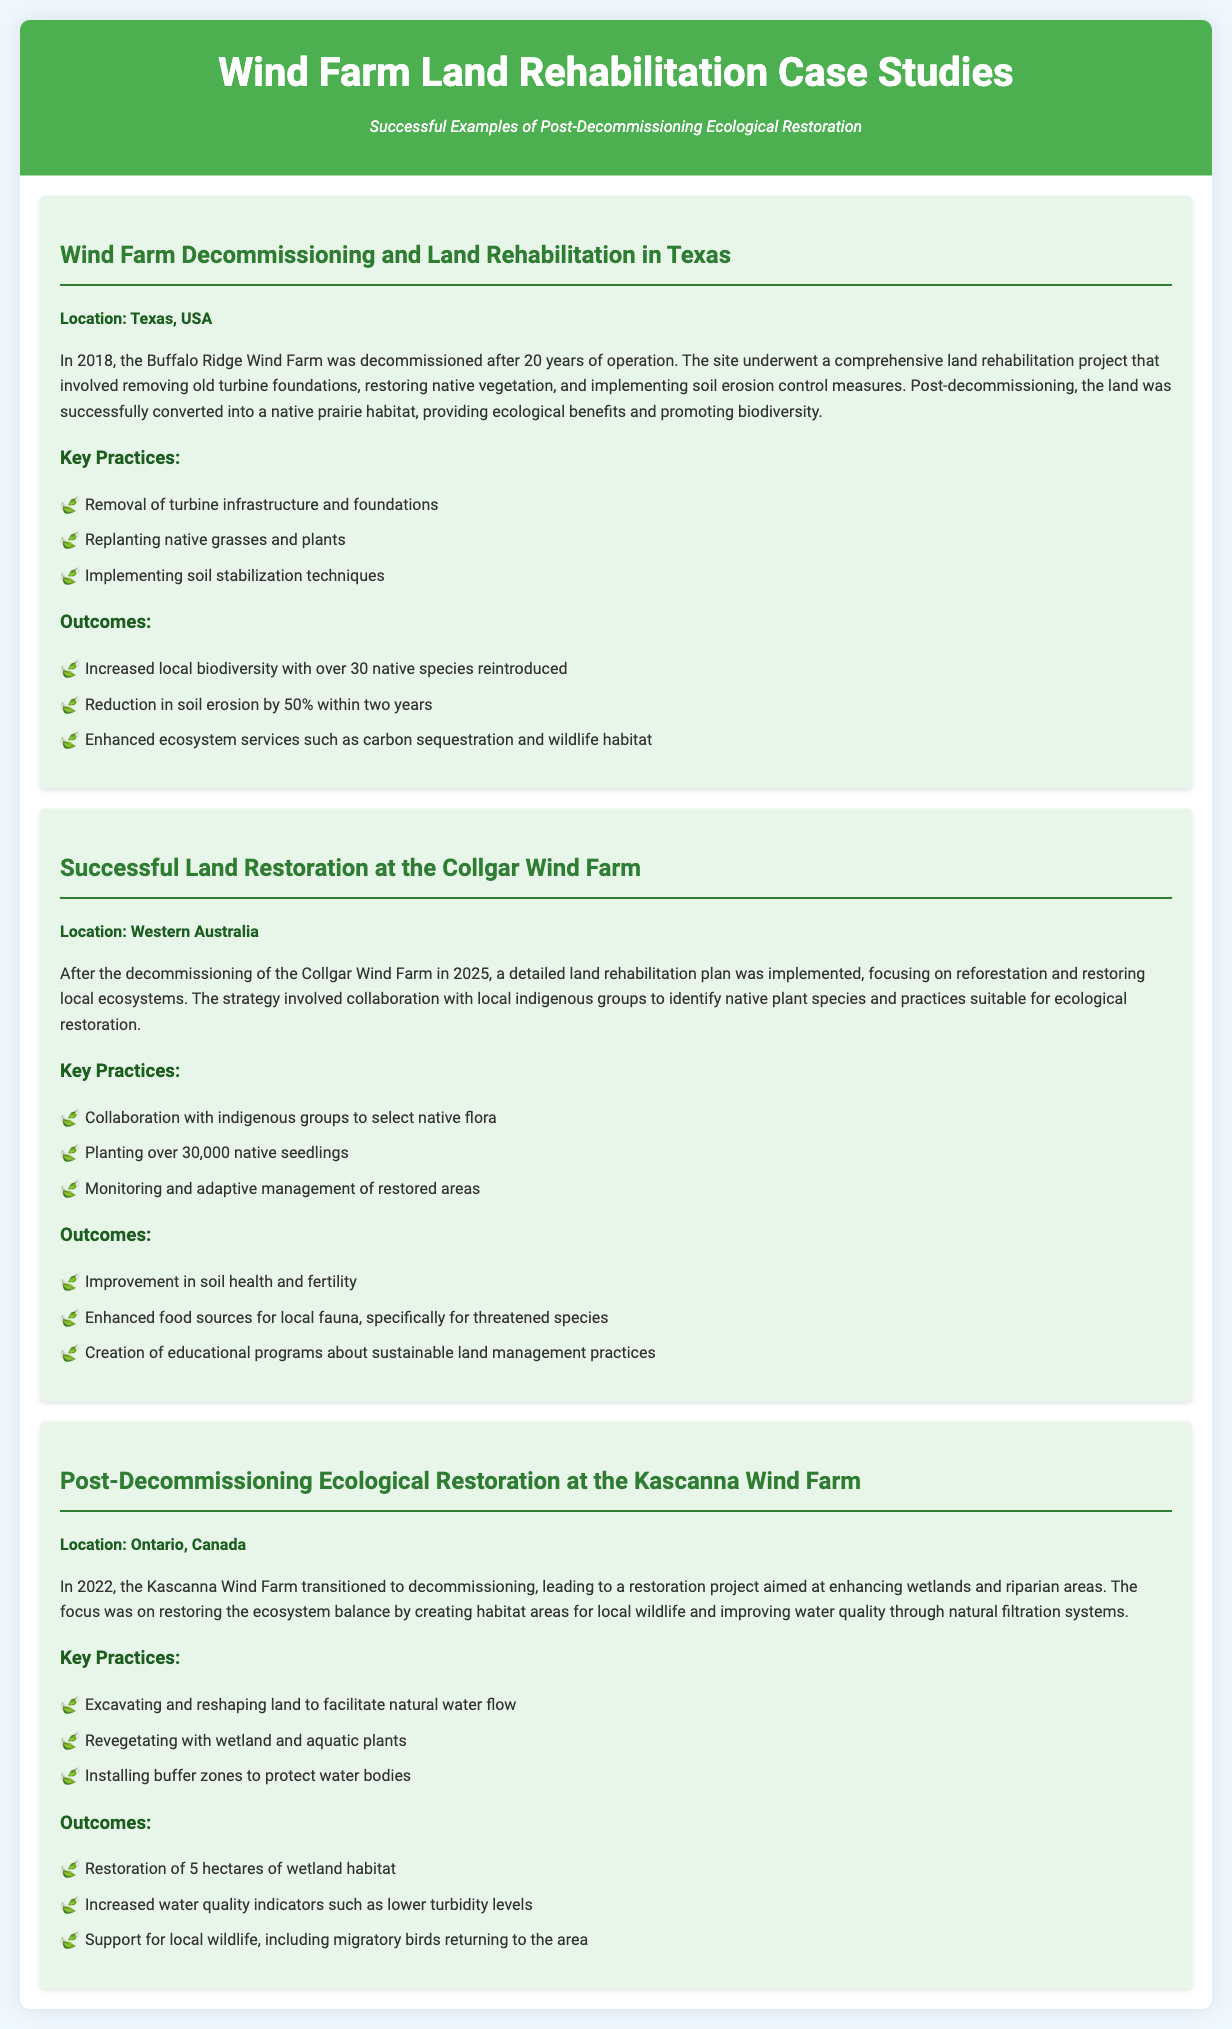What is the location of the Buffalo Ridge Wind Farm case study? The location is specifically mentioned in the case study as Texas, USA.
Answer: Texas, USA When was the Collgar Wind Farm decommissioned? The document states that the decommissioning of the Collgar Wind Farm occurred in 2025.
Answer: 2025 How many native seedlings were planted at the Collgar Wind Farm? The case study indicates that over 30,000 native seedlings were planted.
Answer: 30,000 What was one of the key outcomes of the Kascanna Wind Farm restoration? A key outcome includes the restoration of 5 hectares of wetland habitat.
Answer: 5 hectares What ecological benefit did the Buffalo Ridge Wind Farm restoration provide? The restoration created a native prairie habitat, which is noted to promote biodiversity.
Answer: Native prairie habitat What was a significant focus of the Kascanna Wind Farm restoration project? The focus was on enhancing wetlands and riparian areas, aiming to restore ecosystem balance.
Answer: Enhancing wetlands and riparian areas Which indigenous groups were involved in the restoration at Collgar Wind Farm? The case study highlights collaboration with local indigenous groups for ecological restoration practices.
Answer: Local indigenous groups How much did soil erosion reduce at the Buffalo Ridge site? The document specifies a reduction in soil erosion by 50% within two years post-decommissioning.
Answer: 50% 